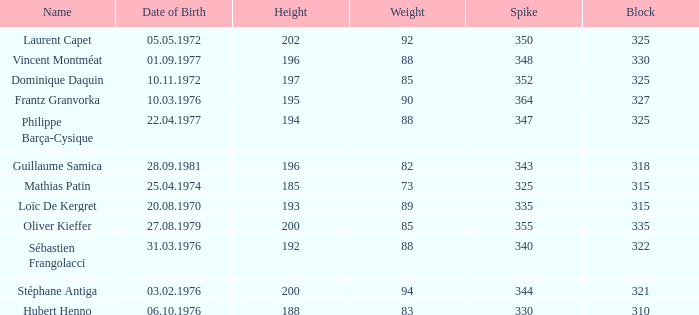How many spikes have 28.09.1981 as the date of birth, with a block greater than 318? None. 